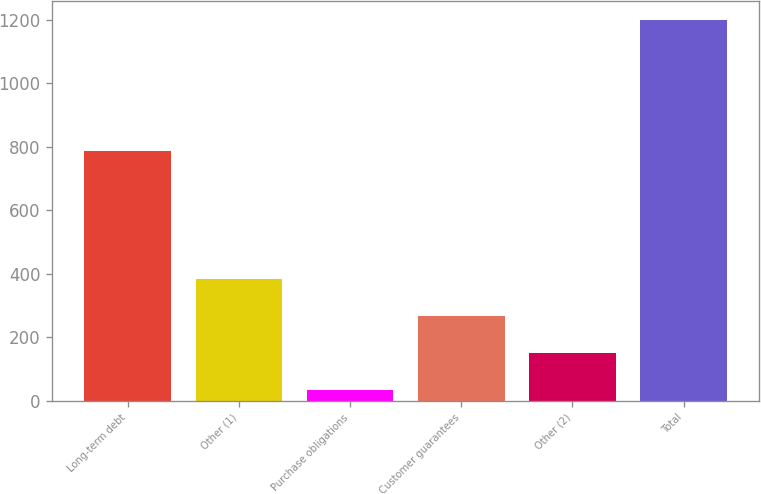<chart> <loc_0><loc_0><loc_500><loc_500><bar_chart><fcel>Long-term debt<fcel>Other (1)<fcel>Purchase obligations<fcel>Customer guarantees<fcel>Other (2)<fcel>Total<nl><fcel>785.2<fcel>382.02<fcel>32.1<fcel>265.38<fcel>148.74<fcel>1198.5<nl></chart> 